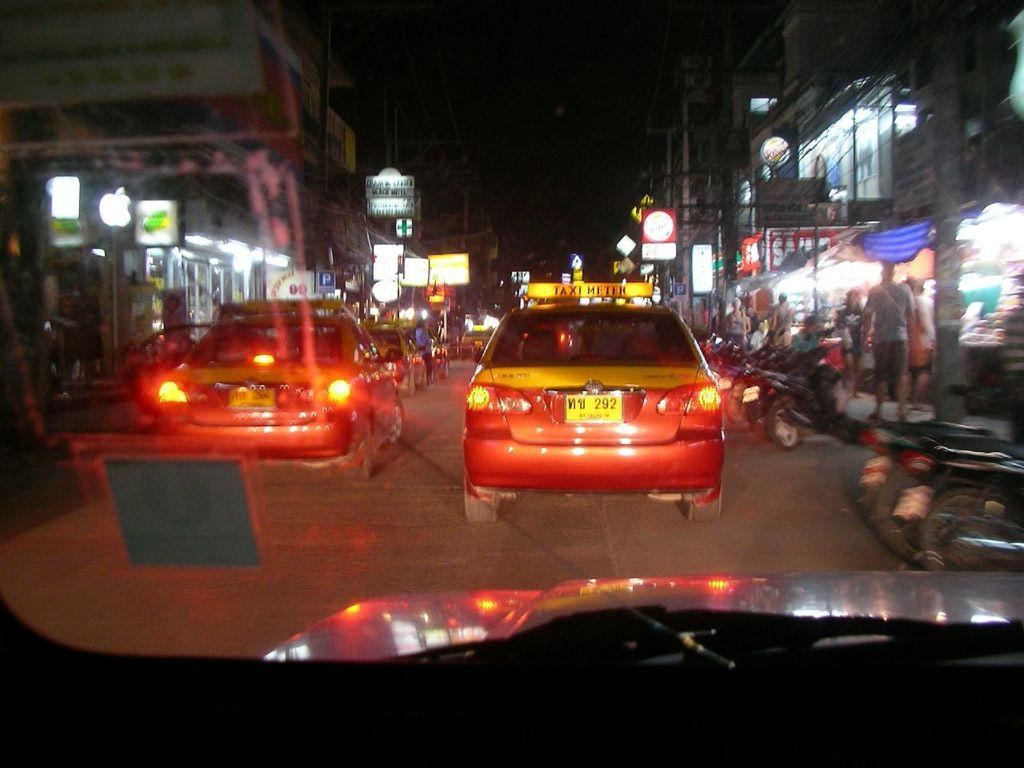<image>
Give a short and clear explanation of the subsequent image. Two cars with taxi meter signs on top, are driving side by side, down a busy street at night. 